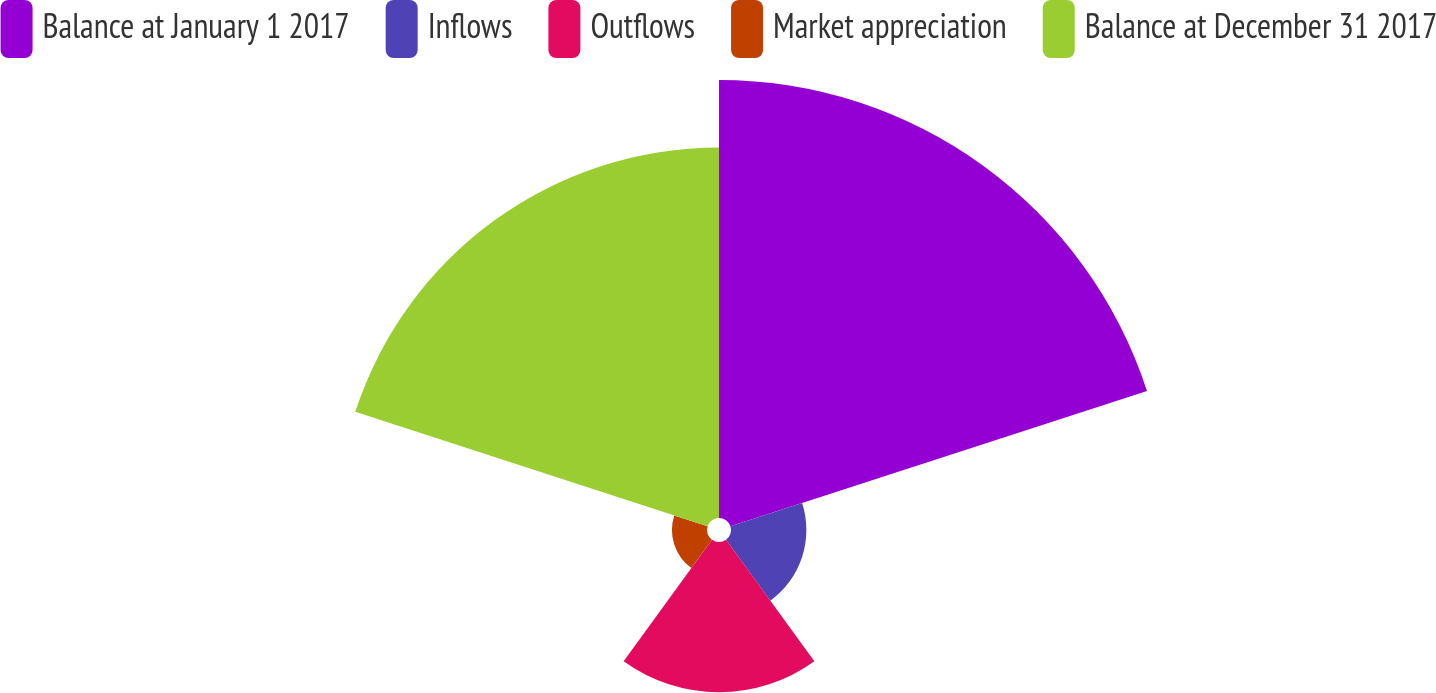<chart> <loc_0><loc_0><loc_500><loc_500><pie_chart><fcel>Balance at January 1 2017<fcel>Inflows<fcel>Outflows<fcel>Market appreciation<fcel>Balance at December 31 2017<nl><fcel>40.97%<fcel>7.05%<fcel>14.05%<fcel>3.28%<fcel>34.65%<nl></chart> 